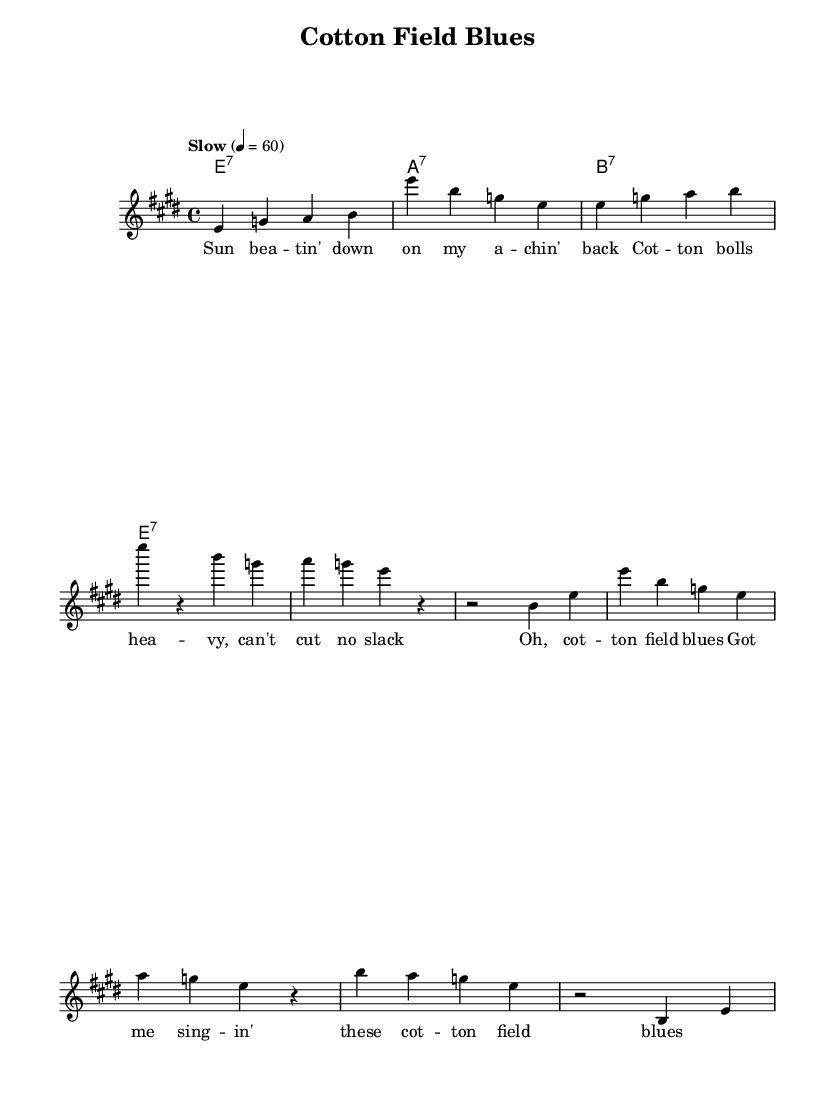What is the key signature of this music? The key signature is indicated at the beginning of the sheet music. The presence of three sharps corresponds to the key of E major.
Answer: E major What is the time signature of this music? The time signature is displayed at the beginning of the score. It shows a "4/4" which means there are four beats per measure.
Answer: 4/4 What is the tempo marking of this piece? The tempo marking is written above the staff and indicates the speed of the piece. It states "Slow" with a specific metronome marking of 60 beats per minute.
Answer: Slow, 60 How many measures are in the intro section? The intro is the first part of the composition, and counting the bars labeled yields a total length. There are two measures in the intro section.
Answer: 2 What chords are used in the harmonies? The harmonies section lists the chords being played alongside the melody. The chords mentioned in the sheet music are E7, A7, and B7.
Answer: E7, A7, B7 How does the chorus relate to the verses? In Blues music, the chorus often serves as a repeated summary of the theme or emotions expressed in the verses. The chorus here repeats certain phrases found in the verses while emphasizing the "cotton field blues."
Answer: Repeated summary, emotional emphasis What is the theme expressed in the lyrics? The lyrics convey a narrative about the hardships faced in rural Southern life, particularly focusing on the struggles of cotton picking and the weight of these experiences.
Answer: Hardships of rural life 